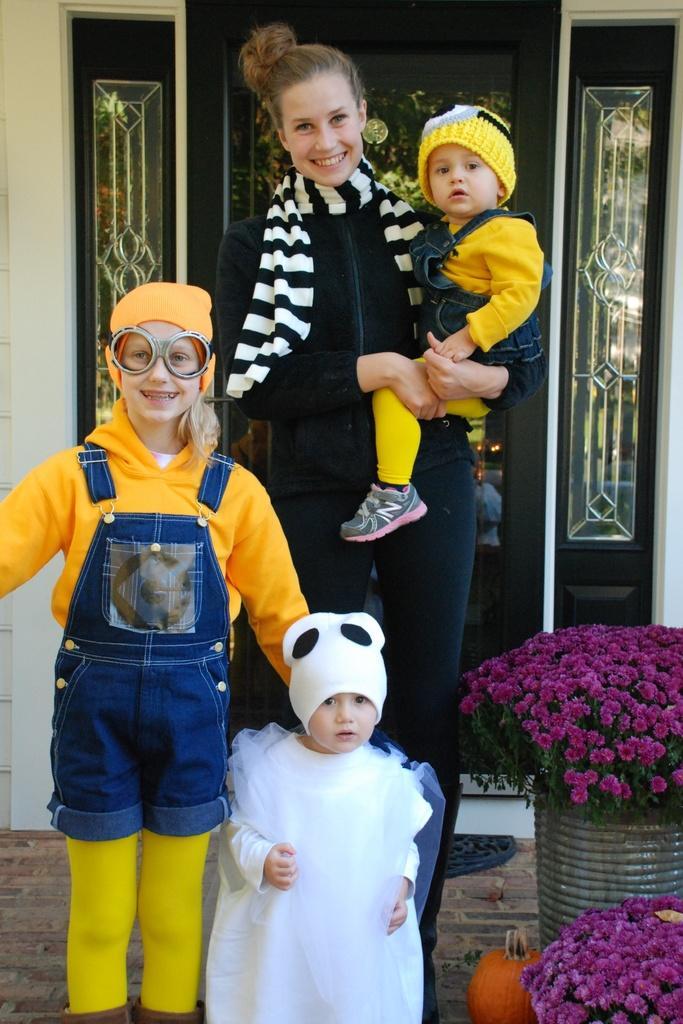Describe this image in one or two sentences. In this image, we can see a woman standing and she is holding a kid, there are two kid standing and there are some flowers, in the background there is a door. 